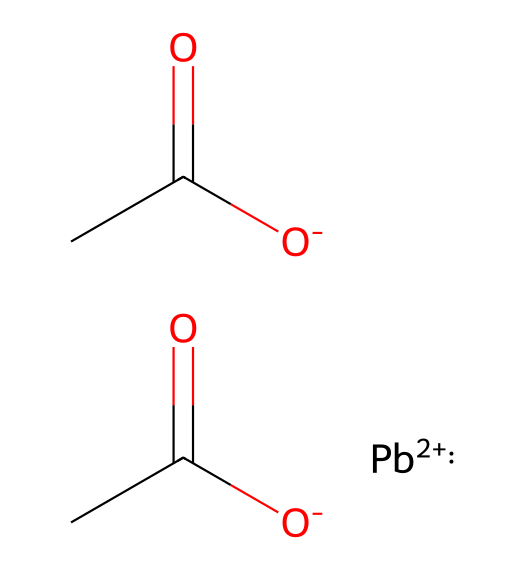What is the chemical formula of lead acetate? The SMILES representation indicates the presence of lead (Pb), carbon (C), hydrogen (H), and oxygen (O) atoms. From the composition observed in the SMILES, the overall formula is C4H6O4Pb.
Answer: C4H6O4Pb How many different elements are present in lead acetate? By analyzing the SMILES notation, we find four distinct elements: lead (Pb), carbon (C), hydrogen (H), and oxygen (O). Thus, the total number of unique elements is four.
Answer: four What is the oxidation state of lead in lead acetate? In the chemical structure, lead is represented as Pb+2, indicating that it is in the +2 oxidation state. Therefore, the oxidation state of lead in this compound is +2.
Answer: +2 How many oxygen atoms are in lead acetate? The SMILES notation shows that there are a total of four oxygen (O) atoms indicated by [O-] sections and (C(=O) parts, which correspond to the carboxylate functional groups. Thus, there are four oxygen atoms.
Answer: four Is lead acetate a solid, liquid, or gas at room temperature? Lead acetate, when considering its typical forms and usage, is primarily found as a solid at room temperature, notably in historical contexts for its use in cosmetics.
Answer: solid What functional groups are present in lead acetate? The chemical structure includes carboxylate groups indicated by the -C(=O)O- portions in the SMILES notation, which are characteristic of organic acids and their derivatives, confirming the presence of carboxylate functional groups.
Answer: carboxylate 